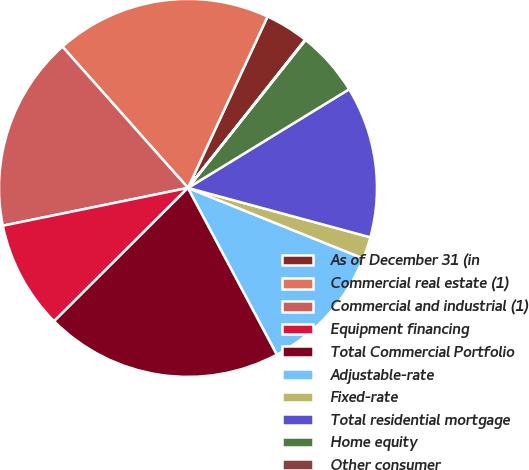Convert chart. <chart><loc_0><loc_0><loc_500><loc_500><pie_chart><fcel>As of December 31 (in<fcel>Commercial real estate (1)<fcel>Commercial and industrial (1)<fcel>Equipment financing<fcel>Total Commercial Portfolio<fcel>Adjustable-rate<fcel>Fixed-rate<fcel>Total residential mortgage<fcel>Home equity<fcel>Other consumer<nl><fcel>3.73%<fcel>18.48%<fcel>16.64%<fcel>9.26%<fcel>20.33%<fcel>11.11%<fcel>1.88%<fcel>12.95%<fcel>5.57%<fcel>0.04%<nl></chart> 